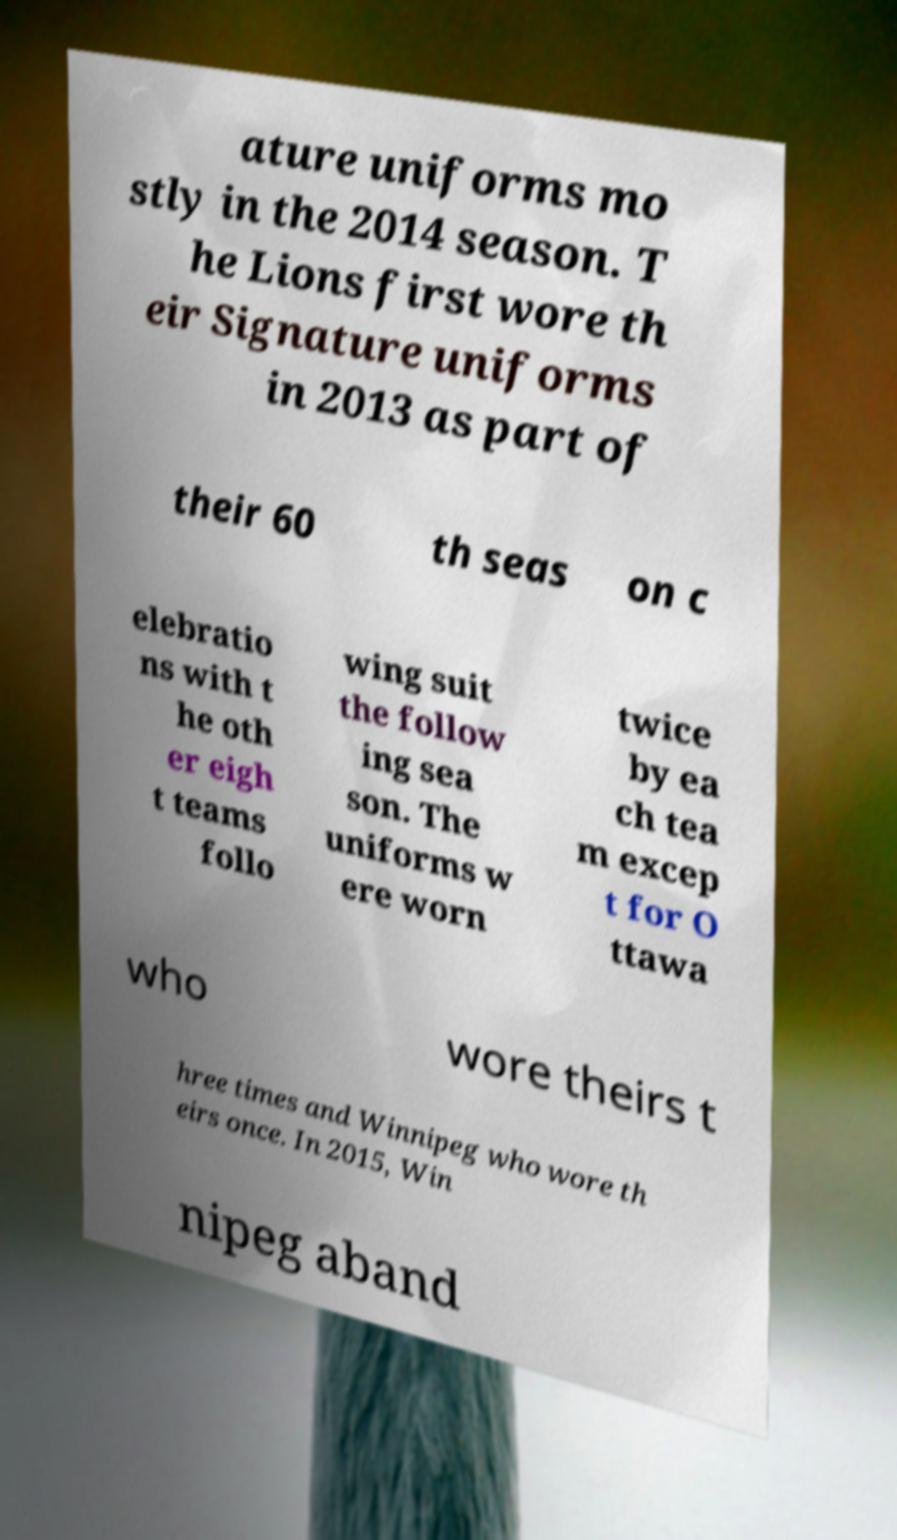Can you accurately transcribe the text from the provided image for me? ature uniforms mo stly in the 2014 season. T he Lions first wore th eir Signature uniforms in 2013 as part of their 60 th seas on c elebratio ns with t he oth er eigh t teams follo wing suit the follow ing sea son. The uniforms w ere worn twice by ea ch tea m excep t for O ttawa who wore theirs t hree times and Winnipeg who wore th eirs once. In 2015, Win nipeg aband 